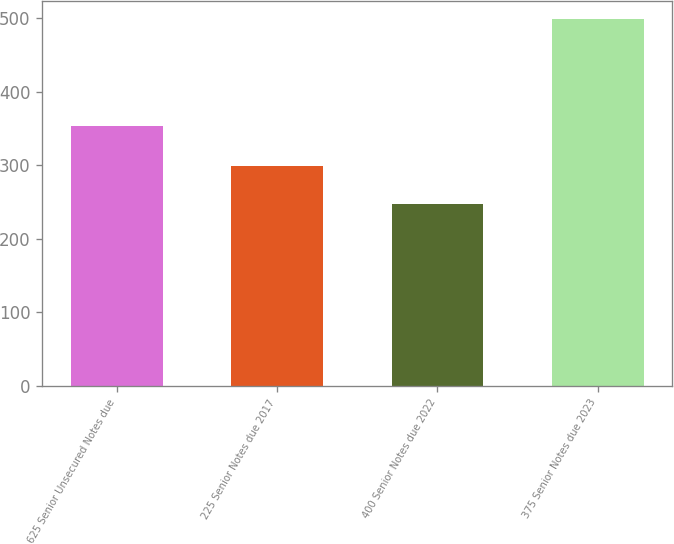Convert chart to OTSL. <chart><loc_0><loc_0><loc_500><loc_500><bar_chart><fcel>625 Senior Unsecured Notes due<fcel>225 Senior Notes due 2017<fcel>400 Senior Notes due 2022<fcel>375 Senior Notes due 2023<nl><fcel>352.8<fcel>299.3<fcel>247.1<fcel>498.5<nl></chart> 